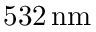<formula> <loc_0><loc_0><loc_500><loc_500>5 3 2 \, n m</formula> 